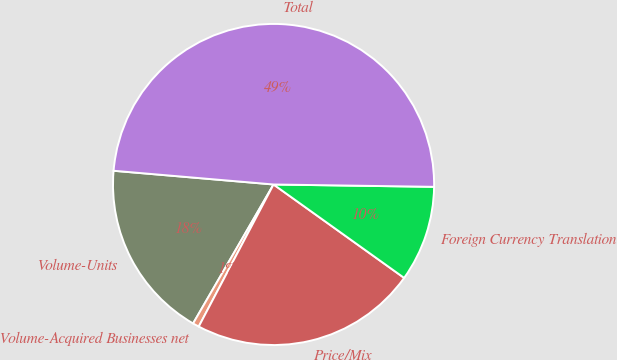Convert chart to OTSL. <chart><loc_0><loc_0><loc_500><loc_500><pie_chart><fcel>Volume-Units<fcel>Volume-Acquired Businesses net<fcel>Price/Mix<fcel>Foreign Currency Translation<fcel>Total<nl><fcel>18.01%<fcel>0.64%<fcel>22.83%<fcel>9.65%<fcel>48.87%<nl></chart> 